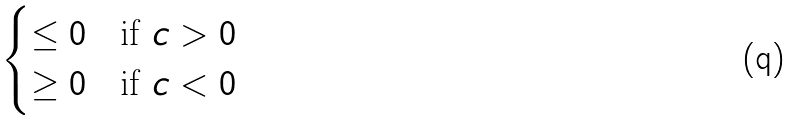<formula> <loc_0><loc_0><loc_500><loc_500>\begin{cases} \leq 0 & \text {if $c>0$} \\ \geq 0 & \text {if $c<0$} \end{cases}</formula> 